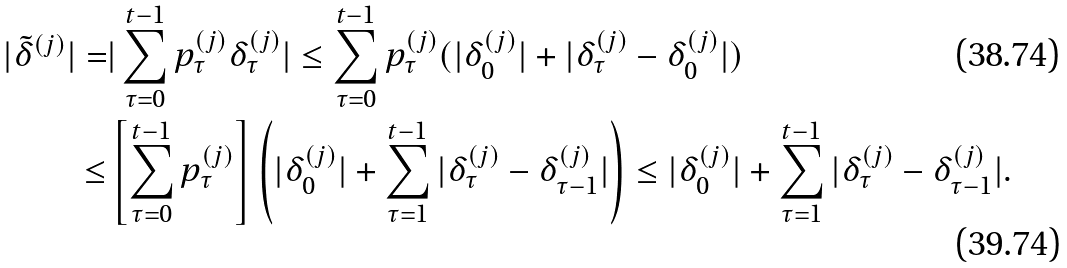<formula> <loc_0><loc_0><loc_500><loc_500>| \tilde { \delta } ^ { ( j ) } | = & | \sum _ { \tau = 0 } ^ { t - 1 } p ^ { ( j ) } _ { \tau } \delta _ { \tau } ^ { ( j ) } | \leq \sum _ { \tau = 0 } ^ { t - 1 } p ^ { ( j ) } _ { \tau } ( | \delta _ { 0 } ^ { ( j ) } | + | \delta _ { \tau } ^ { ( j ) } - \delta _ { 0 } ^ { ( j ) } | ) \\ \leq & \left [ \sum _ { \tau = 0 } ^ { t - 1 } p ^ { ( j ) } _ { \tau } \right ] \left ( | \delta _ { 0 } ^ { ( j ) } | + \sum _ { \tau = 1 } ^ { t - 1 } | \delta _ { \tau } ^ { ( j ) } - \delta _ { \tau - 1 } ^ { ( j ) } | \right ) \leq | \delta _ { 0 } ^ { ( j ) } | + \sum _ { \tau = 1 } ^ { t - 1 } | \delta _ { \tau } ^ { ( j ) } - \delta _ { \tau - 1 } ^ { ( j ) } | .</formula> 